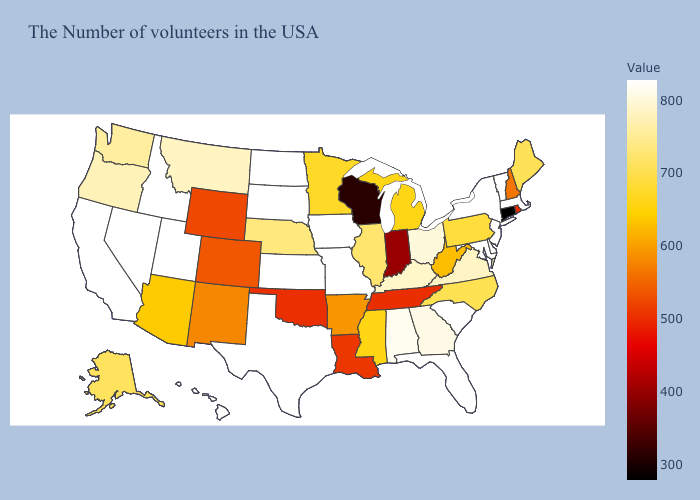Which states hav the highest value in the West?
Concise answer only. Utah, Idaho, Nevada, California, Hawaii. Does Ohio have the highest value in the MidWest?
Be succinct. No. Does Florida have the highest value in the USA?
Be succinct. Yes. Among the states that border New Jersey , does Pennsylvania have the highest value?
Be succinct. No. Which states hav the highest value in the MidWest?
Concise answer only. Missouri, Iowa, Kansas, South Dakota, North Dakota. Does Iowa have the highest value in the USA?
Quick response, please. Yes. Does Connecticut have the highest value in the USA?
Concise answer only. No. 